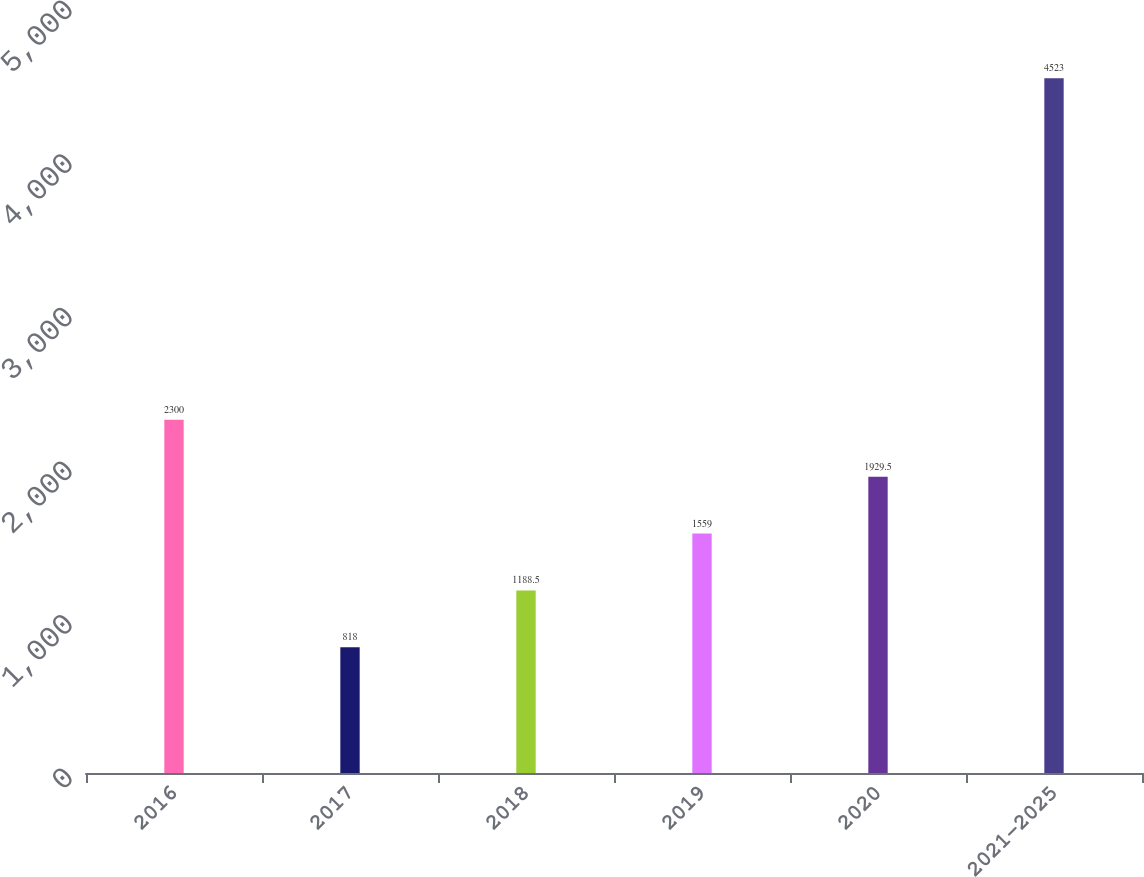<chart> <loc_0><loc_0><loc_500><loc_500><bar_chart><fcel>2016<fcel>2017<fcel>2018<fcel>2019<fcel>2020<fcel>2021-2025<nl><fcel>2300<fcel>818<fcel>1188.5<fcel>1559<fcel>1929.5<fcel>4523<nl></chart> 